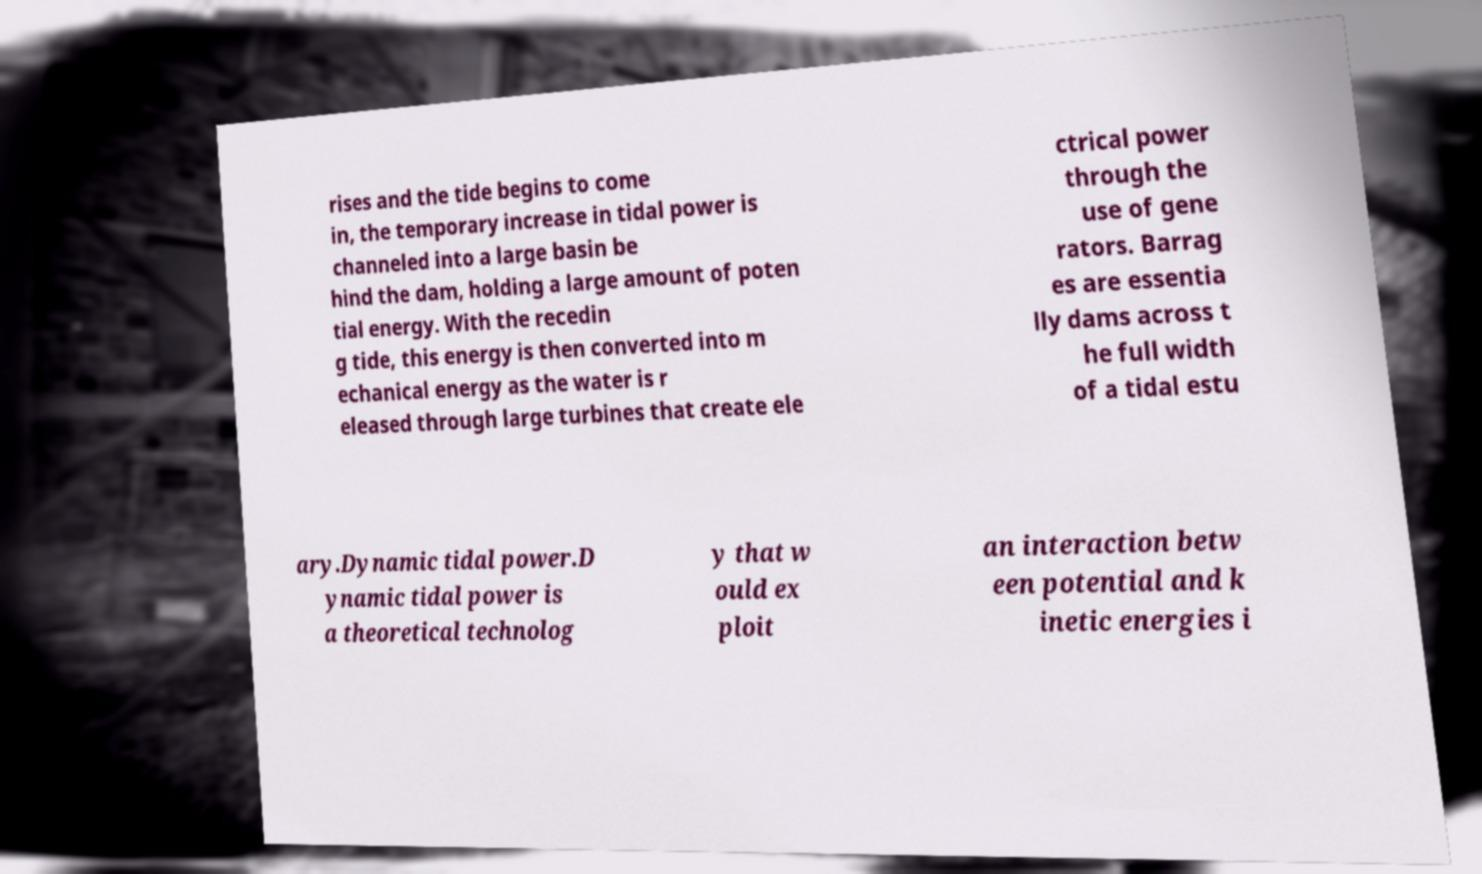For documentation purposes, I need the text within this image transcribed. Could you provide that? rises and the tide begins to come in, the temporary increase in tidal power is channeled into a large basin be hind the dam, holding a large amount of poten tial energy. With the recedin g tide, this energy is then converted into m echanical energy as the water is r eleased through large turbines that create ele ctrical power through the use of gene rators. Barrag es are essentia lly dams across t he full width of a tidal estu ary.Dynamic tidal power.D ynamic tidal power is a theoretical technolog y that w ould ex ploit an interaction betw een potential and k inetic energies i 